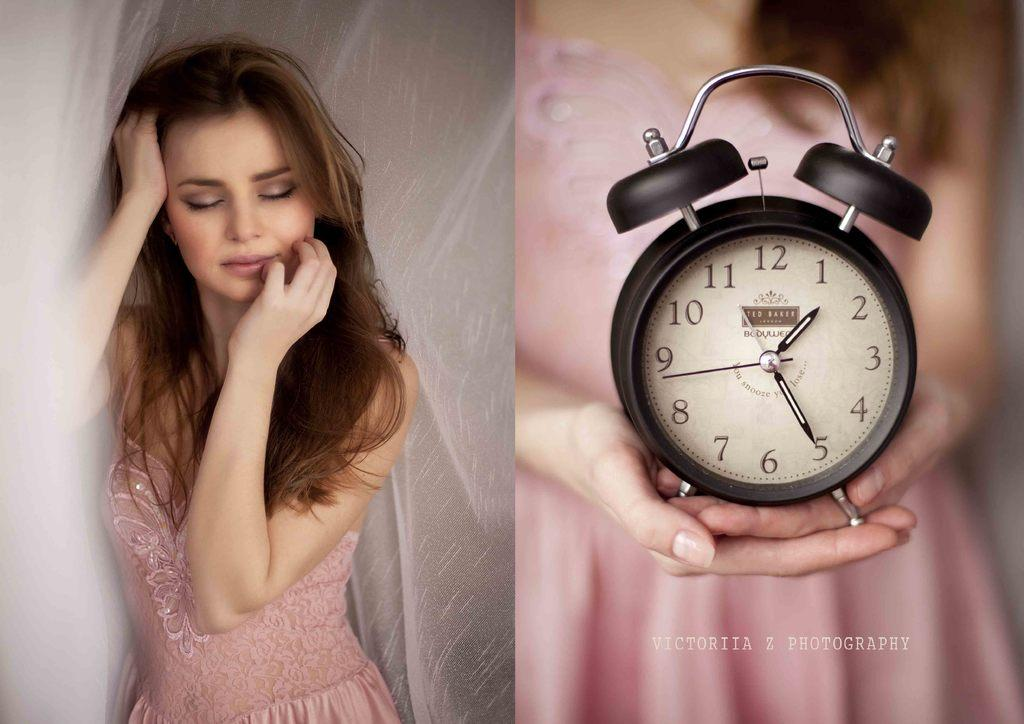<image>
Present a compact description of the photo's key features. Two hands hold an old alarm clock reading 1:20, by Victoria Z Photography. 